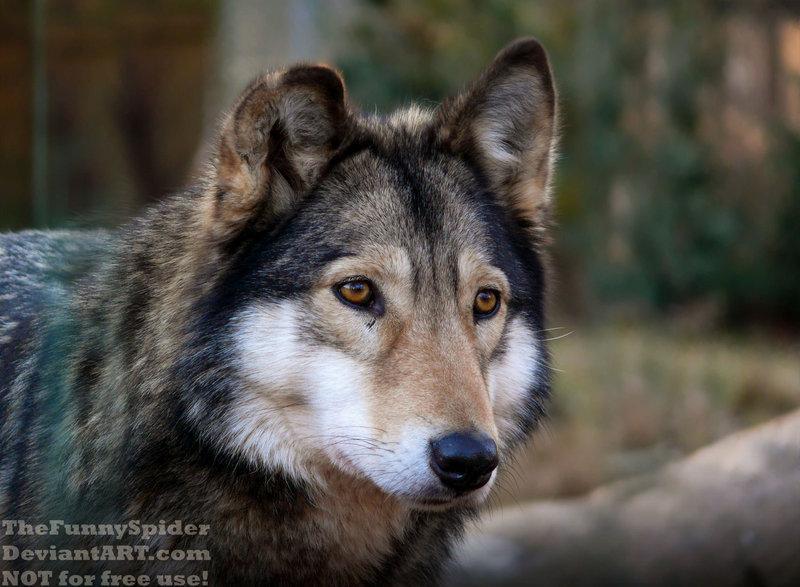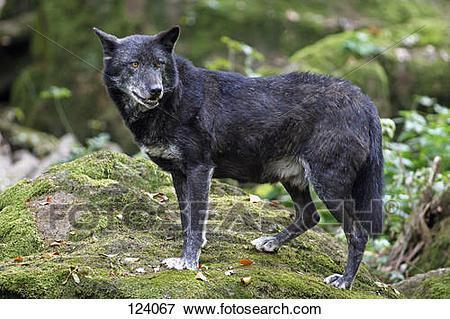The first image is the image on the left, the second image is the image on the right. Assess this claim about the two images: "One of the wolves is howling facing left.". Correct or not? Answer yes or no. No. The first image is the image on the left, the second image is the image on the right. Analyze the images presented: Is the assertion "The right image includes a rightward-turned wolf with its head and neck raised, eyes closed, and mouth open in a howling pose." valid? Answer yes or no. No. 